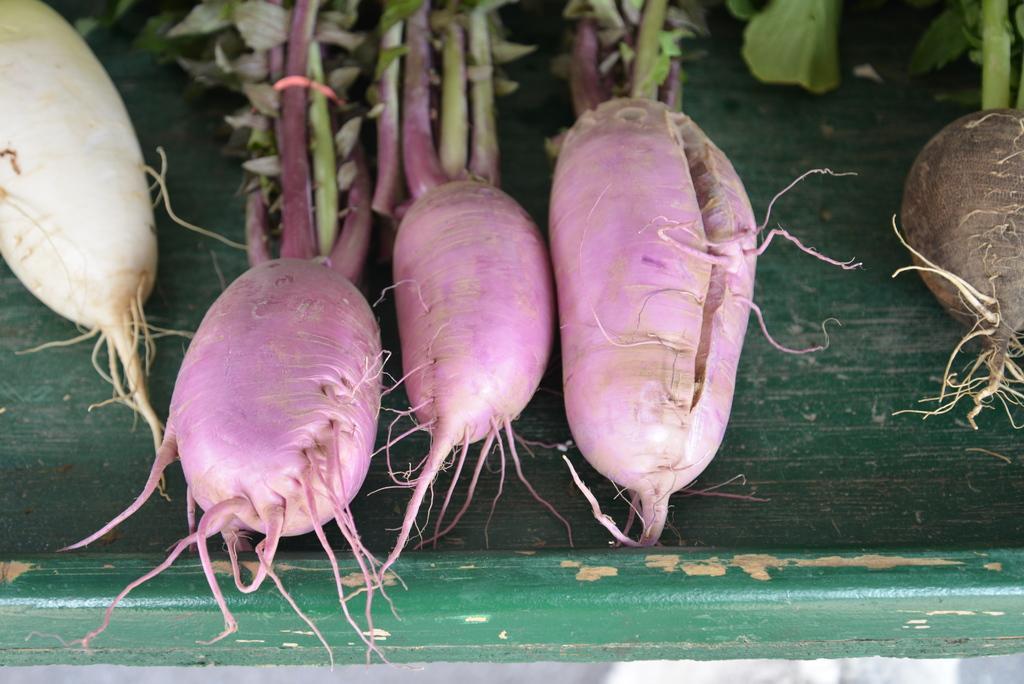How would you summarize this image in a sentence or two? In this picture we can see some different colors of reddish to the plant. 